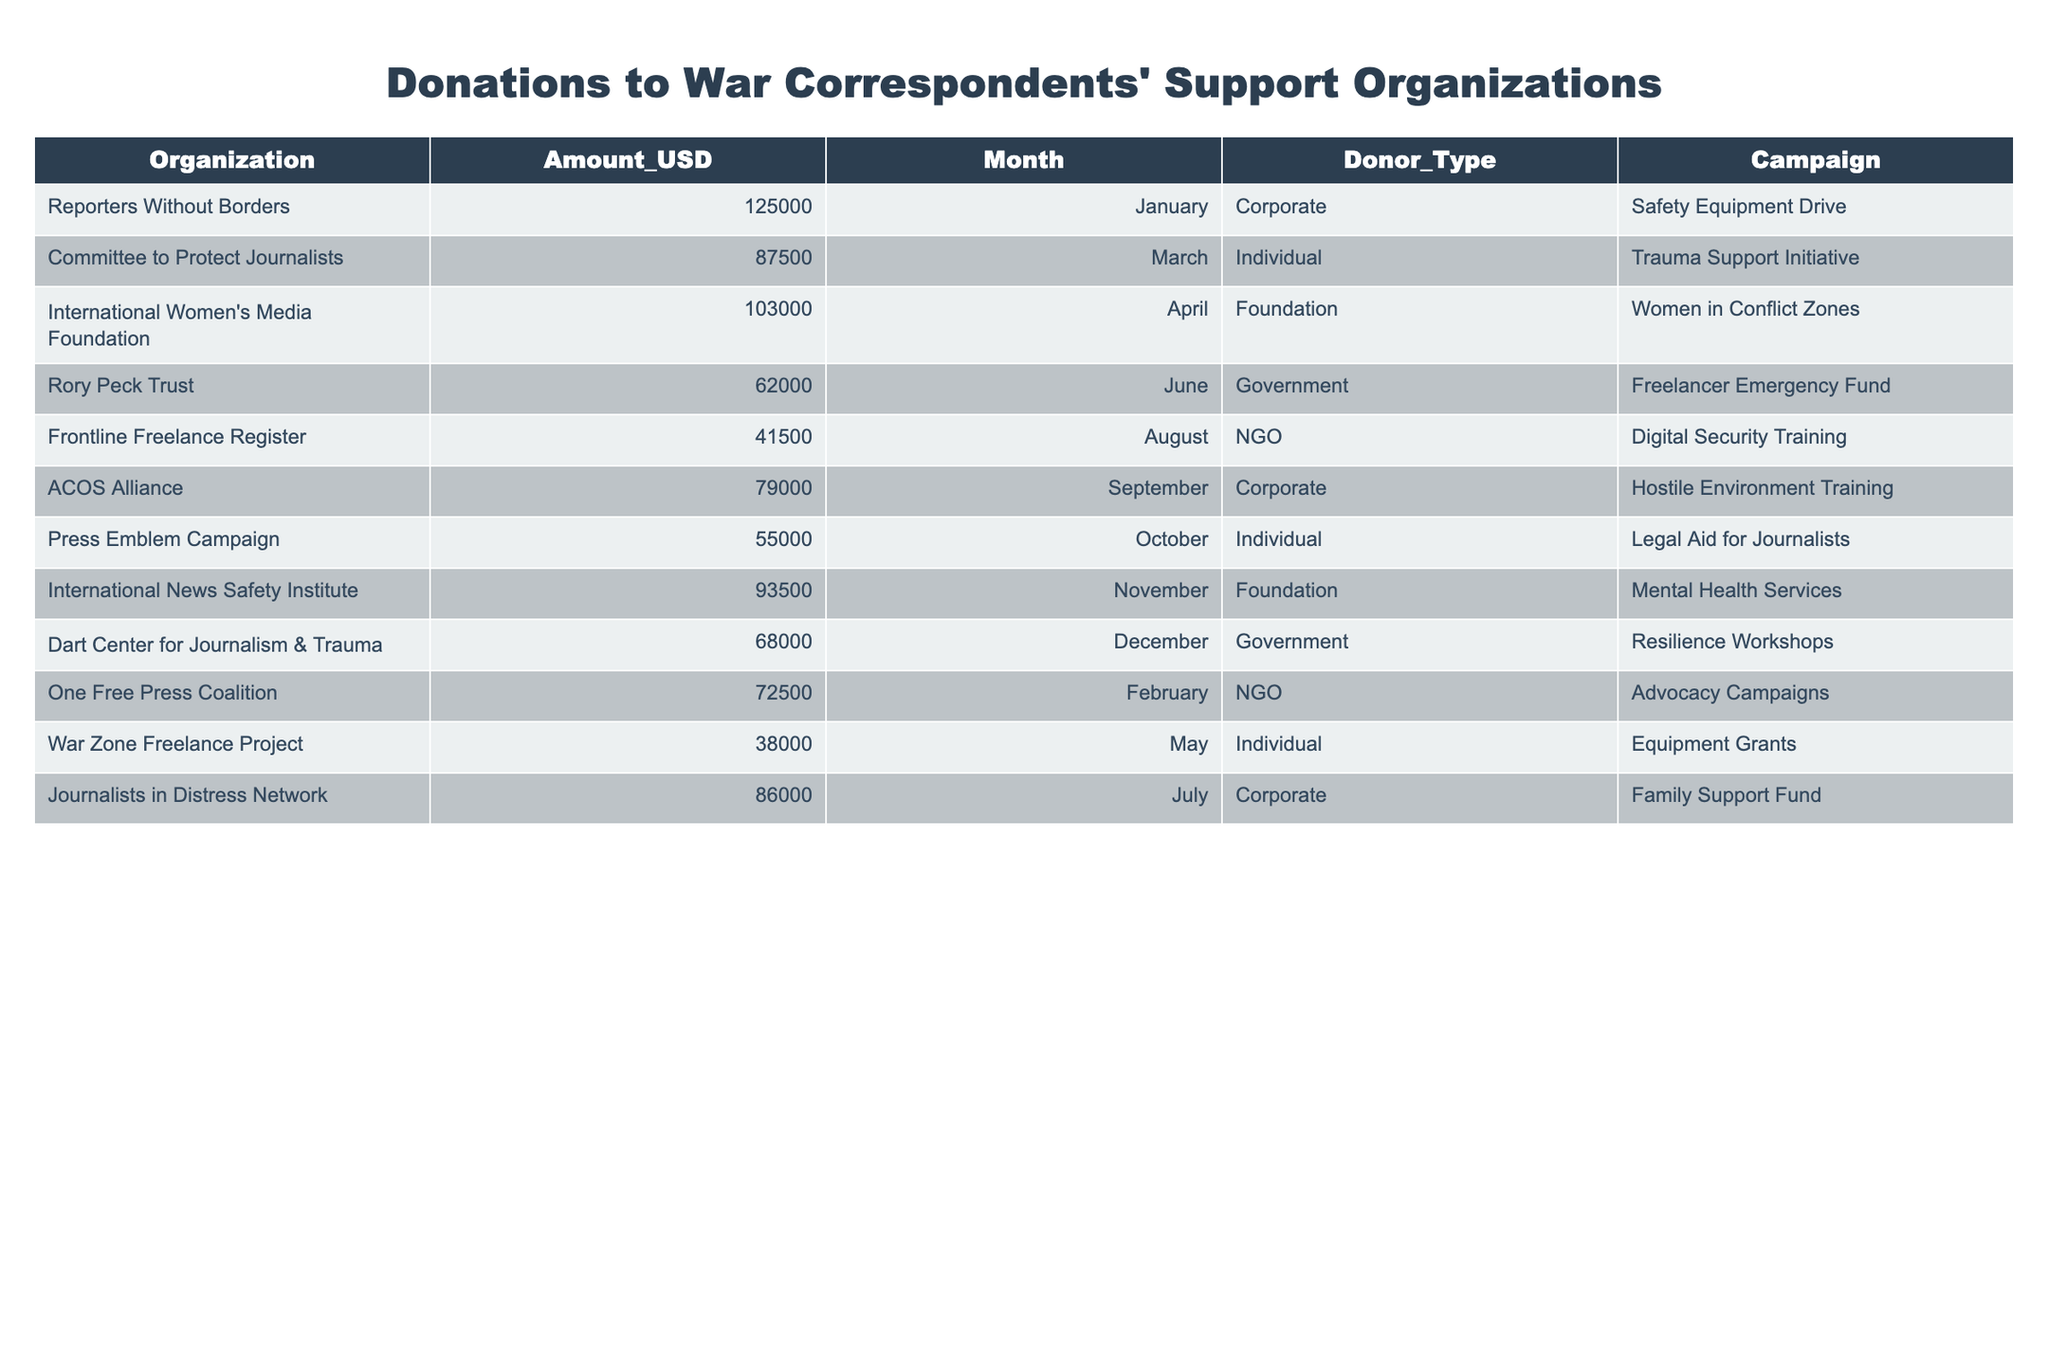What organization received the highest amount in donations? By inspecting the 'Amount_USD' column, I can see that 'Reporters Without Borders' has the highest donation amount of $125,000, as it is the only entry above $100,000.
Answer: Reporters Without Borders Which month received the least total donations? To find out the month with the least total donations, I would sum up the donations for each month. The monthly sums are: January ($125,000), February ($72,500), March ($87,500), April ($103,000), May ($38,000), June ($62,000), July ($86,000), August ($41,500), September ($79,000), October ($55,000), November ($93,500), December ($68,000). The month with the least total is May with $38,000.
Answer: May Which donor type contributed the most money overall? By grouping the donations by 'Donor_Type' and summing them up, we find: Corporate ($300,500), Individual ($198,500), Foundation ($192,000), Government ($140,000), NGO ($115,500). Corporate has the highest total donation amount of $300,500.
Answer: Corporate Was the total amount donated by individual donors greater than that from foundations? The total for individual donors is $198,500, and for foundations, it is $192,000. Since $198,500 is greater than $192,000, the statement is true.
Answer: Yes How much more did 'Reporters Without Borders' receive compared to 'War Zone Freelance Project'? The donation for 'Reporters Without Borders' is $125,000 and for 'War Zone Freelance Project' it is $38,000. The difference can be calculated as $125,000 - $38,000 = $87,000.
Answer: $87,000 What was the average donation amount across all organizations? To find the average donation, I would sum up all donation amounts ($125,000 + $87,500 + $103,000 + $62,000 + $41,500 + $79,000 + $55,000 + $93,500 + $68,000 + $72,500 + $38,000 + $86,000) which equals $843,000 and divide by the number of organizations (12). So, $843,000 / 12 = $70,250.
Answer: $70,250 Did any organization receive donations in every month of the year? I analyze the 'Organization' column against the number of unique months to see if any organization appears in each month (January to December). Each organization appears only once, indicating none received donations in every month.
Answer: No 